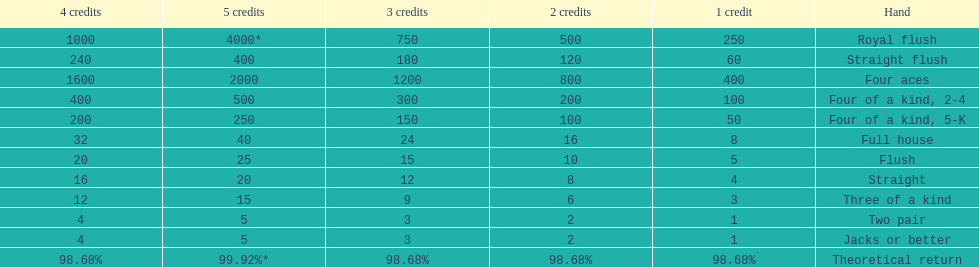Is four 5s worth more or less than four 2s? Less. 